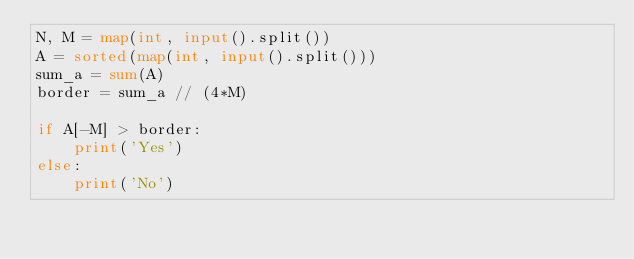<code> <loc_0><loc_0><loc_500><loc_500><_Python_>N, M = map(int, input().split())
A = sorted(map(int, input().split()))
sum_a = sum(A)
border = sum_a // (4*M)

if A[-M] > border:
    print('Yes')
else:
    print('No')</code> 